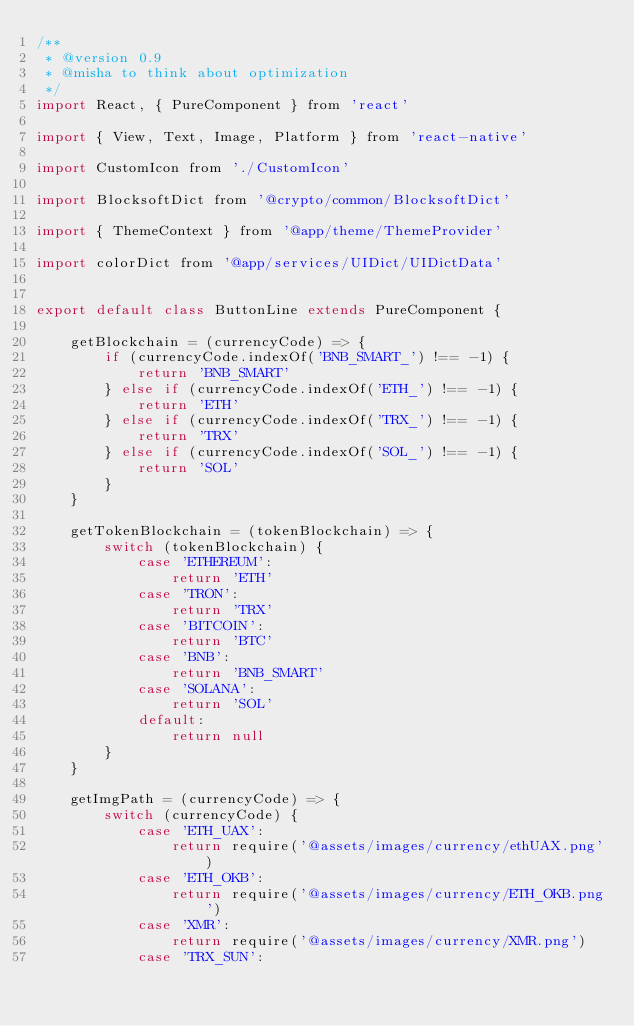<code> <loc_0><loc_0><loc_500><loc_500><_JavaScript_>/**
 * @version 0.9
 * @misha to think about optimization
 */
import React, { PureComponent } from 'react'

import { View, Text, Image, Platform } from 'react-native'

import CustomIcon from './CustomIcon'

import BlocksoftDict from '@crypto/common/BlocksoftDict'

import { ThemeContext } from '@app/theme/ThemeProvider'

import colorDict from '@app/services/UIDict/UIDictData'


export default class ButtonLine extends PureComponent {

    getBlockchain = (currencyCode) => {
        if (currencyCode.indexOf('BNB_SMART_') !== -1) {
            return 'BNB_SMART'
        } else if (currencyCode.indexOf('ETH_') !== -1) {
            return 'ETH'
        } else if (currencyCode.indexOf('TRX_') !== -1) {
            return 'TRX'
        } else if (currencyCode.indexOf('SOL_') !== -1) {
            return 'SOL'
        }
    }

    getTokenBlockchain = (tokenBlockchain) => {
        switch (tokenBlockchain) {
            case 'ETHEREUM':
                return 'ETH'
            case 'TRON':
                return 'TRX'
            case 'BITCOIN':
                return 'BTC'
            case 'BNB':
                return 'BNB_SMART'
            case 'SOLANA':
                return 'SOL'
            default:
                return null
        }
    }

    getImgPath = (currencyCode) => {
        switch (currencyCode) {
            case 'ETH_UAX':
                return require('@assets/images/currency/ethUAX.png')
            case 'ETH_OKB':
                return require('@assets/images/currency/ETH_OKB.png')
            case 'XMR':
                return require('@assets/images/currency/XMR.png')
            case 'TRX_SUN':</code> 